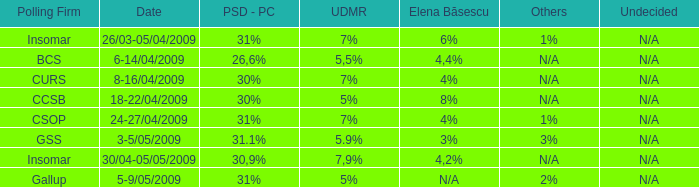When the other is n/a and the psc-pc is 30% what is the date? 8-16/04/2009, 18-22/04/2009. 